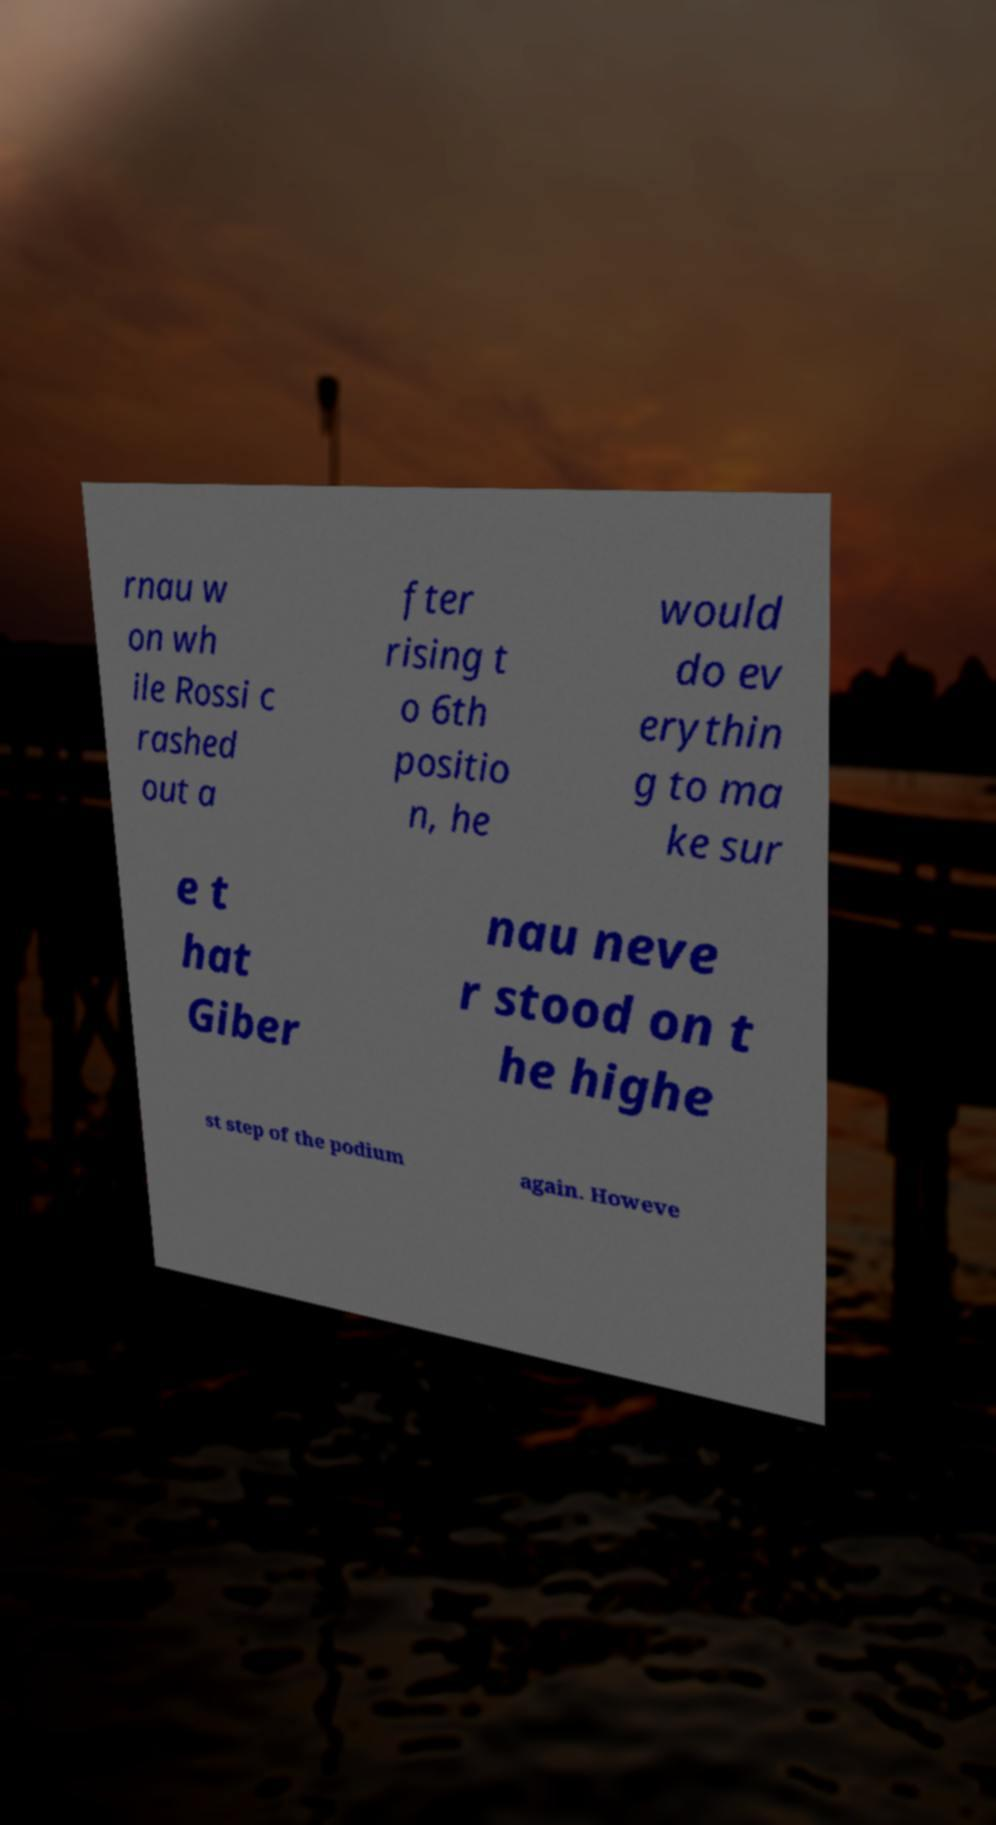What messages or text are displayed in this image? I need them in a readable, typed format. rnau w on wh ile Rossi c rashed out a fter rising t o 6th positio n, he would do ev erythin g to ma ke sur e t hat Giber nau neve r stood on t he highe st step of the podium again. Howeve 